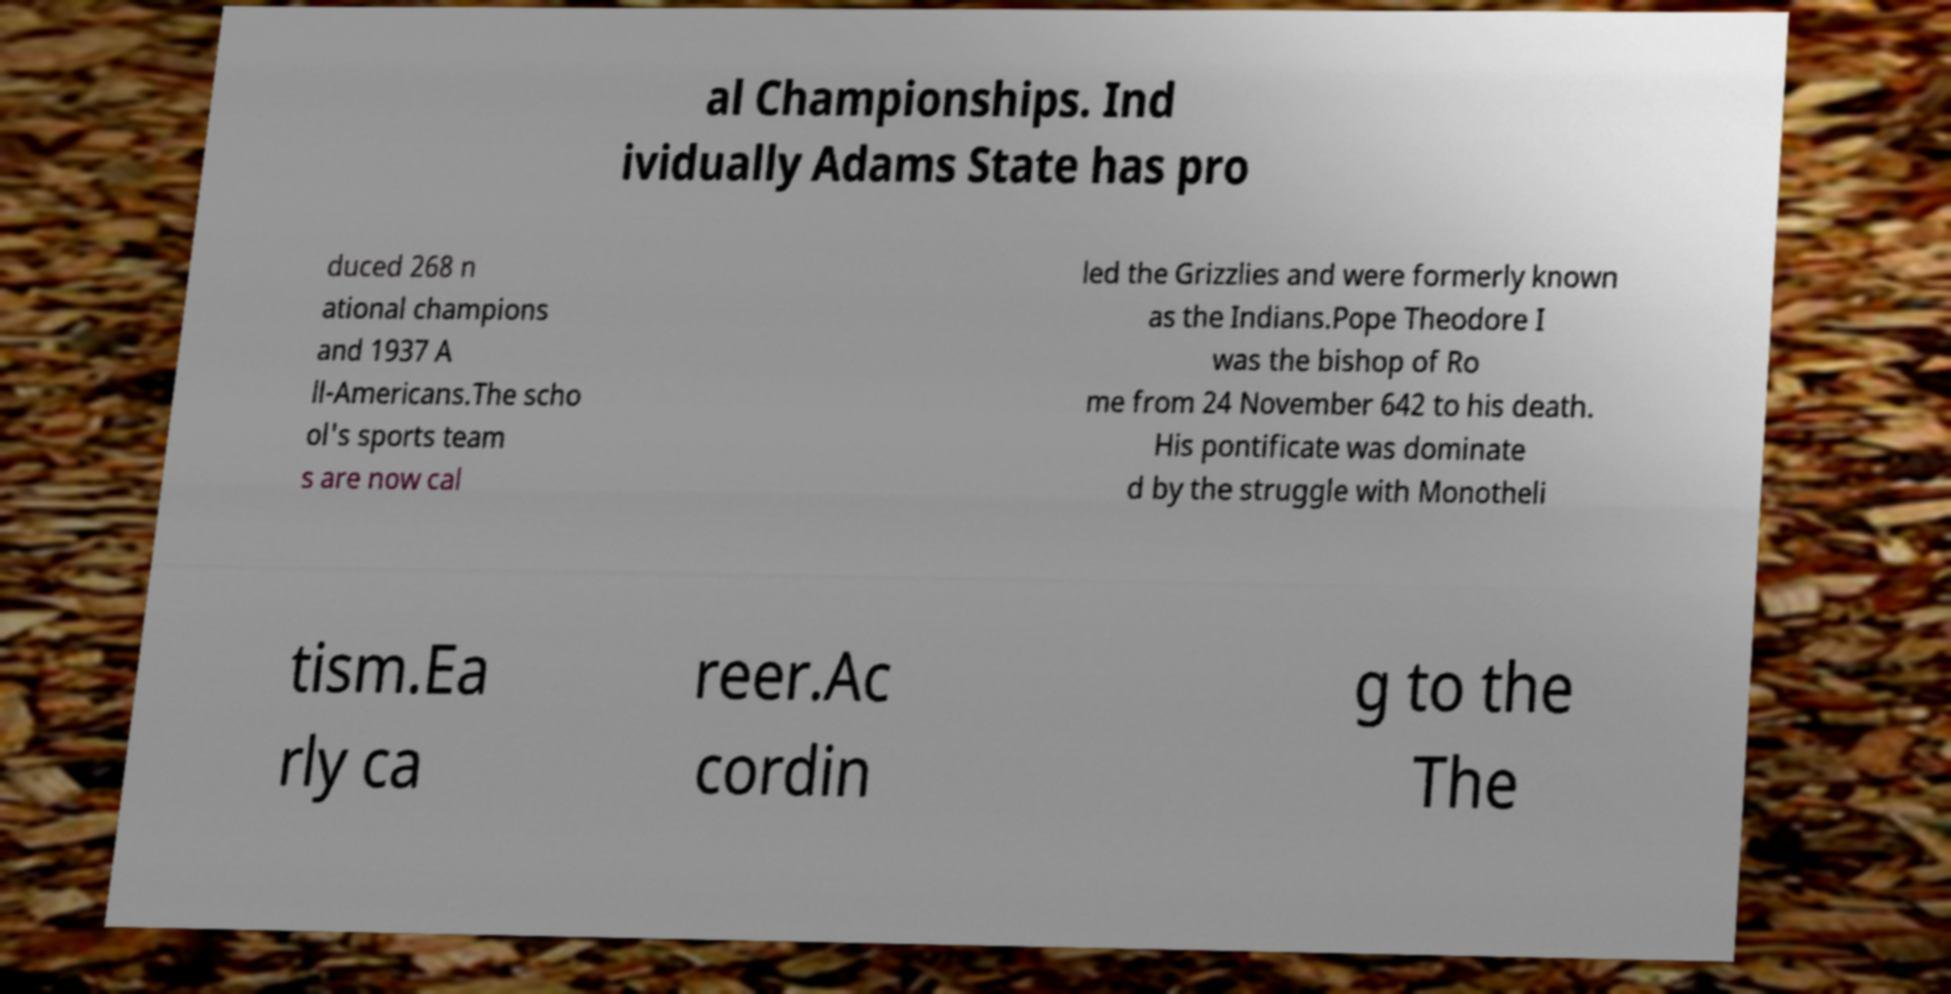Please read and relay the text visible in this image. What does it say? al Championships. Ind ividually Adams State has pro duced 268 n ational champions and 1937 A ll-Americans.The scho ol's sports team s are now cal led the Grizzlies and were formerly known as the Indians.Pope Theodore I was the bishop of Ro me from 24 November 642 to his death. His pontificate was dominate d by the struggle with Monotheli tism.Ea rly ca reer.Ac cordin g to the The 